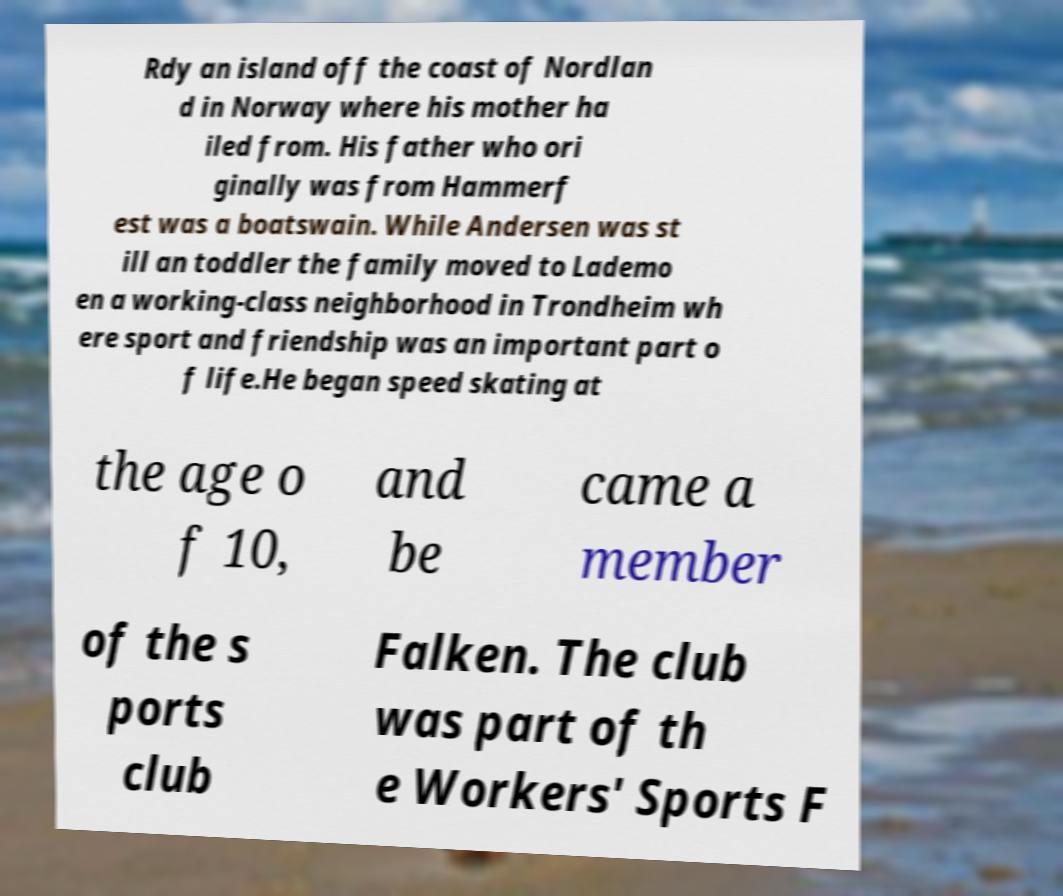What messages or text are displayed in this image? I need them in a readable, typed format. Rdy an island off the coast of Nordlan d in Norway where his mother ha iled from. His father who ori ginally was from Hammerf est was a boatswain. While Andersen was st ill an toddler the family moved to Lademo en a working-class neighborhood in Trondheim wh ere sport and friendship was an important part o f life.He began speed skating at the age o f 10, and be came a member of the s ports club Falken. The club was part of th e Workers' Sports F 